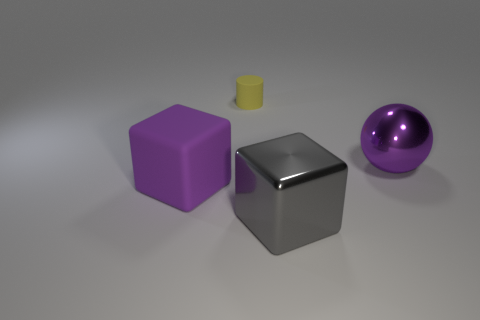Add 4 large gray rubber objects. How many objects exist? 8 Subtract all spheres. How many objects are left? 3 Add 4 gray cylinders. How many gray cylinders exist? 4 Subtract 0 green cubes. How many objects are left? 4 Subtract all red matte spheres. Subtract all cubes. How many objects are left? 2 Add 4 big cubes. How many big cubes are left? 6 